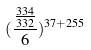Convert formula to latex. <formula><loc_0><loc_0><loc_500><loc_500>( \frac { \frac { 3 3 4 } { 3 3 2 } } { 6 } ) ^ { 3 7 + 2 5 5 }</formula> 